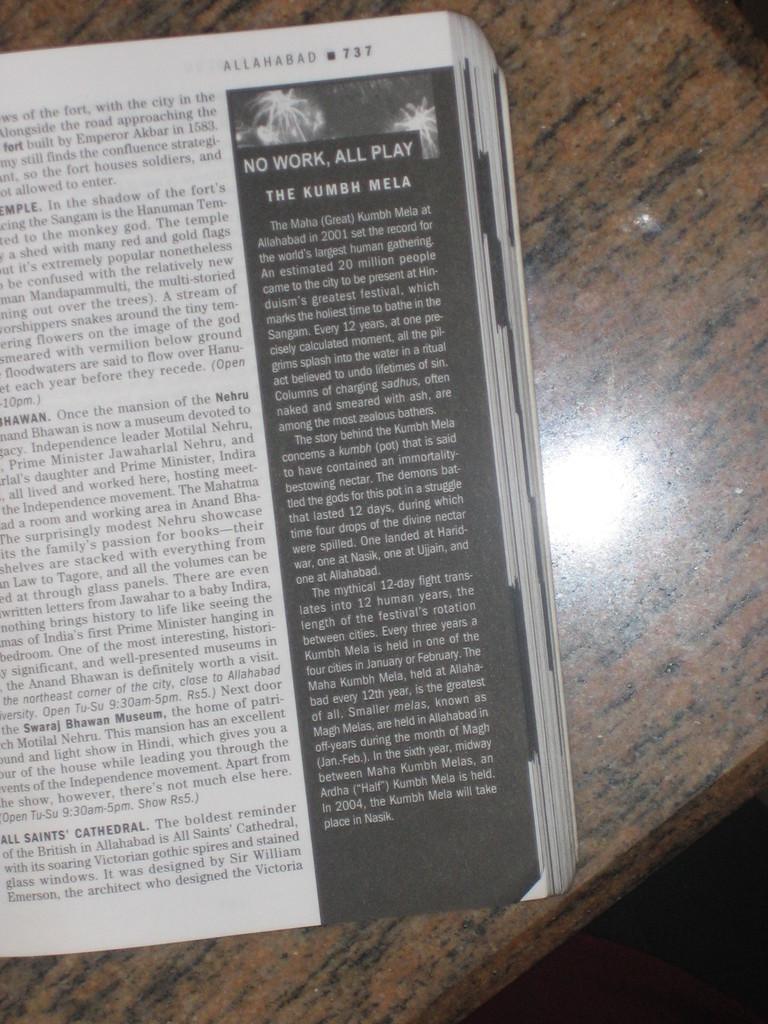What is the book about?
Keep it short and to the point. Unanswerable. No work, all what?
Your answer should be very brief. Play. 